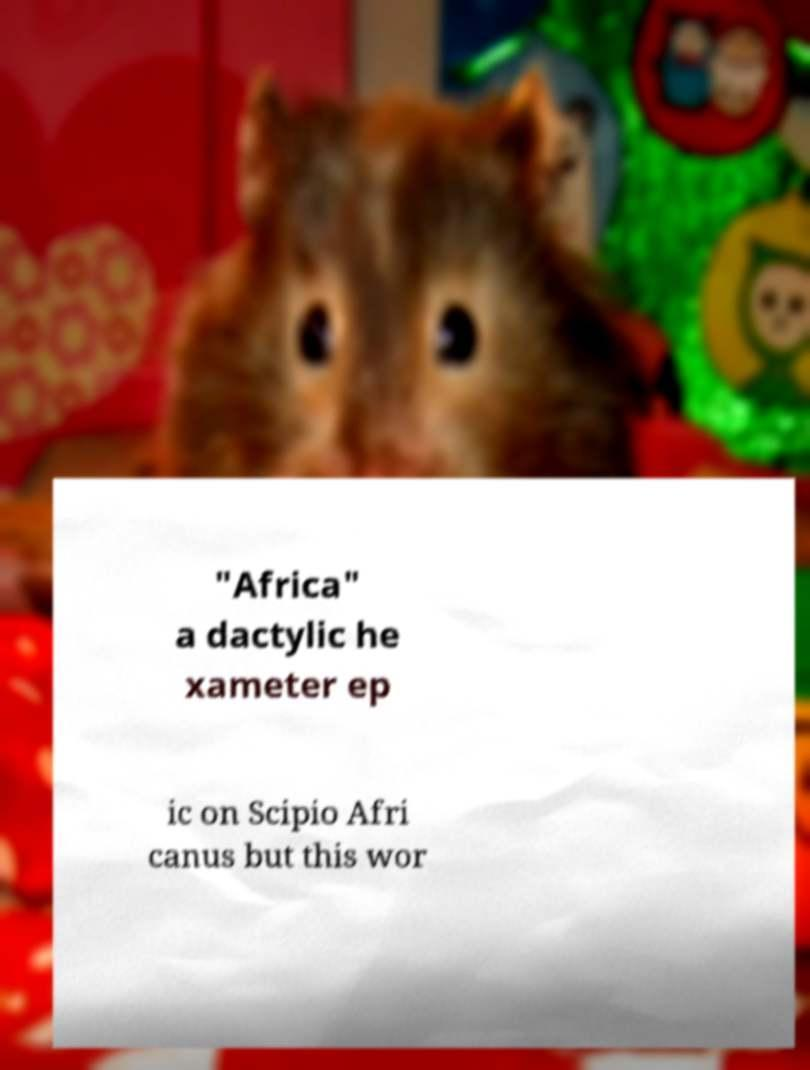Could you assist in decoding the text presented in this image and type it out clearly? "Africa" a dactylic he xameter ep ic on Scipio Afri canus but this wor 